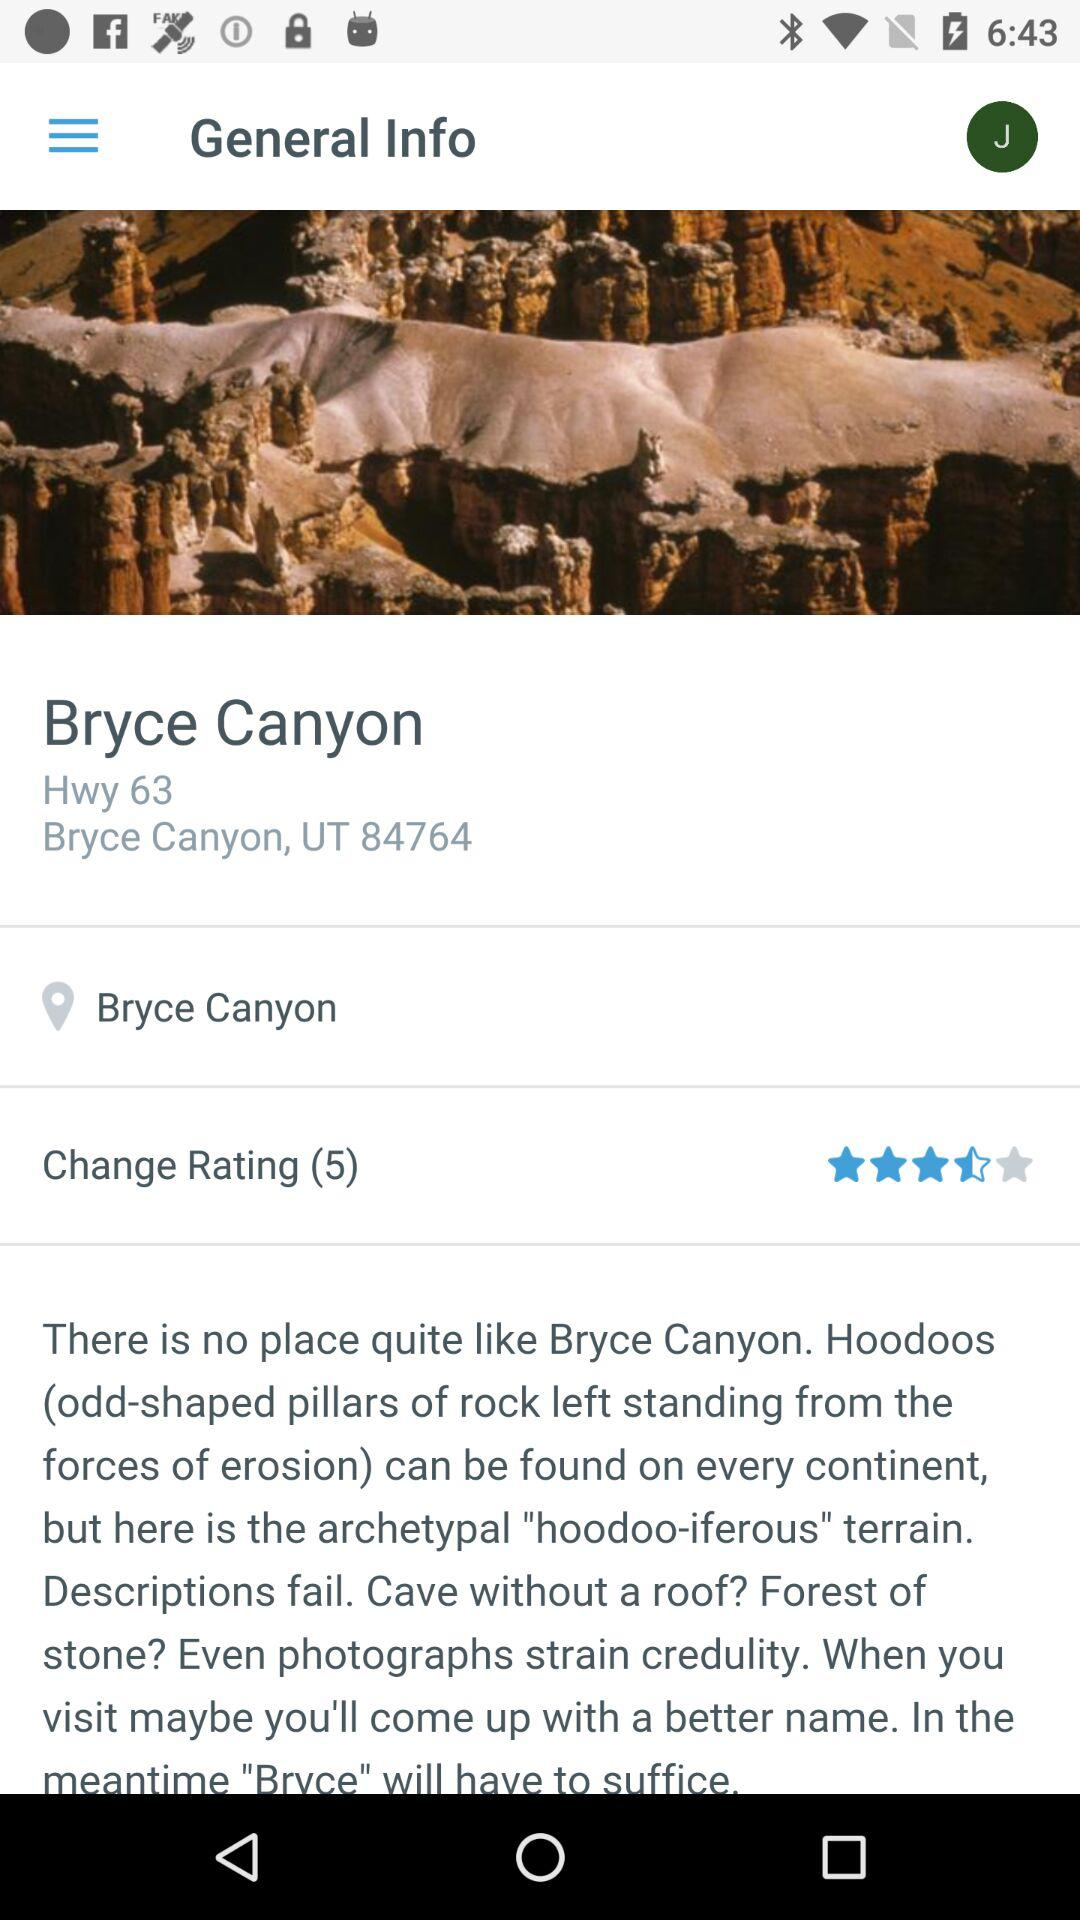What is the address of "Bryce Canyon"? The address of "Bryce Canyon" is Hwy 63, Bryce Canyon, UT 84764. 